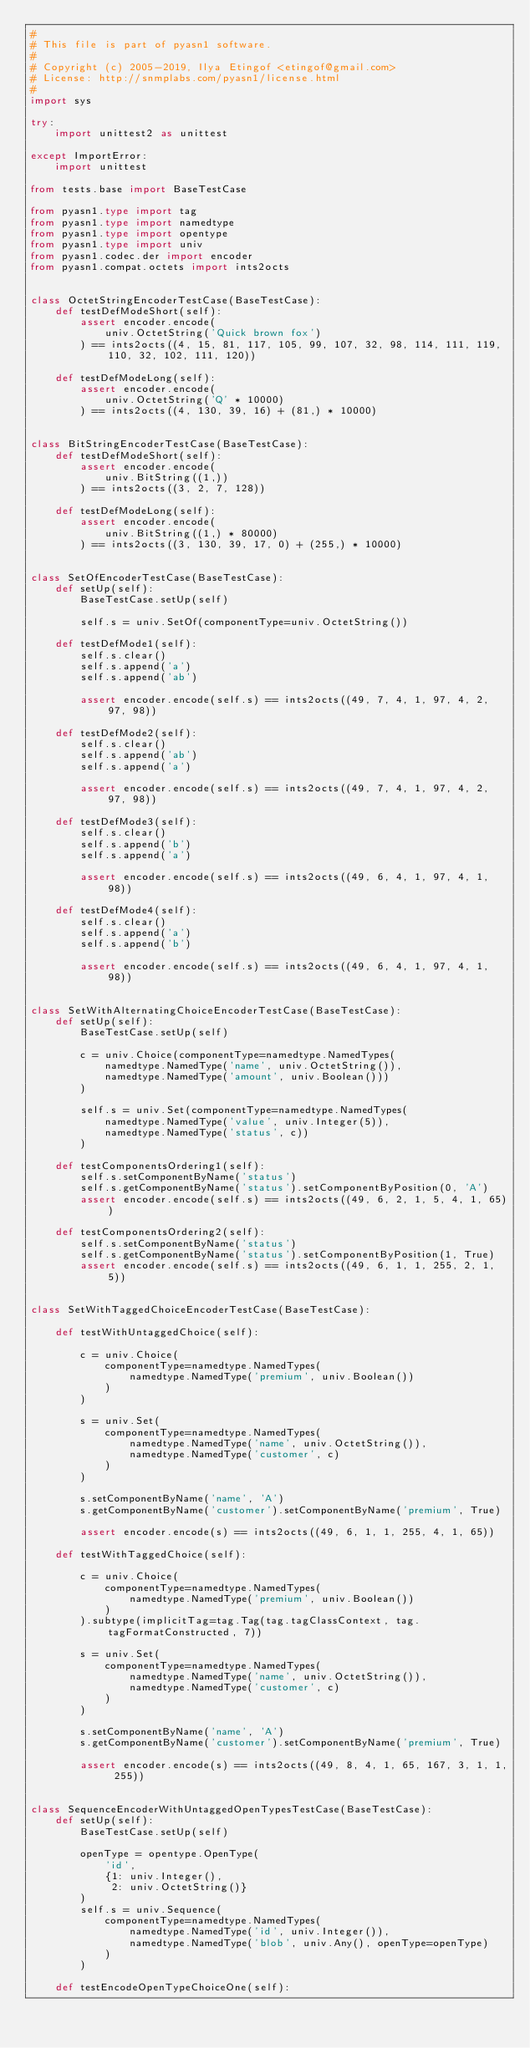<code> <loc_0><loc_0><loc_500><loc_500><_Python_>#
# This file is part of pyasn1 software.
#
# Copyright (c) 2005-2019, Ilya Etingof <etingof@gmail.com>
# License: http://snmplabs.com/pyasn1/license.html
#
import sys

try:
    import unittest2 as unittest

except ImportError:
    import unittest

from tests.base import BaseTestCase

from pyasn1.type import tag
from pyasn1.type import namedtype
from pyasn1.type import opentype
from pyasn1.type import univ
from pyasn1.codec.der import encoder
from pyasn1.compat.octets import ints2octs


class OctetStringEncoderTestCase(BaseTestCase):
    def testDefModeShort(self):
        assert encoder.encode(
            univ.OctetString('Quick brown fox')
        ) == ints2octs((4, 15, 81, 117, 105, 99, 107, 32, 98, 114, 111, 119, 110, 32, 102, 111, 120))

    def testDefModeLong(self):
        assert encoder.encode(
            univ.OctetString('Q' * 10000)
        ) == ints2octs((4, 130, 39, 16) + (81,) * 10000)


class BitStringEncoderTestCase(BaseTestCase):
    def testDefModeShort(self):
        assert encoder.encode(
            univ.BitString((1,))
        ) == ints2octs((3, 2, 7, 128))

    def testDefModeLong(self):
        assert encoder.encode(
            univ.BitString((1,) * 80000)
        ) == ints2octs((3, 130, 39, 17, 0) + (255,) * 10000)


class SetOfEncoderTestCase(BaseTestCase):
    def setUp(self):
        BaseTestCase.setUp(self)

        self.s = univ.SetOf(componentType=univ.OctetString())

    def testDefMode1(self):
        self.s.clear()
        self.s.append('a')
        self.s.append('ab')

        assert encoder.encode(self.s) == ints2octs((49, 7, 4, 1, 97, 4, 2, 97, 98))

    def testDefMode2(self):
        self.s.clear()
        self.s.append('ab')
        self.s.append('a')

        assert encoder.encode(self.s) == ints2octs((49, 7, 4, 1, 97, 4, 2, 97, 98))

    def testDefMode3(self):
        self.s.clear()
        self.s.append('b')
        self.s.append('a')

        assert encoder.encode(self.s) == ints2octs((49, 6, 4, 1, 97, 4, 1, 98))

    def testDefMode4(self):
        self.s.clear()
        self.s.append('a')
        self.s.append('b')

        assert encoder.encode(self.s) == ints2octs((49, 6, 4, 1, 97, 4, 1, 98))


class SetWithAlternatingChoiceEncoderTestCase(BaseTestCase):
    def setUp(self):
        BaseTestCase.setUp(self)

        c = univ.Choice(componentType=namedtype.NamedTypes(
            namedtype.NamedType('name', univ.OctetString()),
            namedtype.NamedType('amount', univ.Boolean()))
        )

        self.s = univ.Set(componentType=namedtype.NamedTypes(
            namedtype.NamedType('value', univ.Integer(5)),
            namedtype.NamedType('status', c))
        )

    def testComponentsOrdering1(self):
        self.s.setComponentByName('status')
        self.s.getComponentByName('status').setComponentByPosition(0, 'A')
        assert encoder.encode(self.s) == ints2octs((49, 6, 2, 1, 5, 4, 1, 65))

    def testComponentsOrdering2(self):
        self.s.setComponentByName('status')
        self.s.getComponentByName('status').setComponentByPosition(1, True)
        assert encoder.encode(self.s) == ints2octs((49, 6, 1, 1, 255, 2, 1, 5))


class SetWithTaggedChoiceEncoderTestCase(BaseTestCase):

    def testWithUntaggedChoice(self):

        c = univ.Choice(
            componentType=namedtype.NamedTypes(
                namedtype.NamedType('premium', univ.Boolean())
            )
        )

        s = univ.Set(
            componentType=namedtype.NamedTypes(
                namedtype.NamedType('name', univ.OctetString()),
                namedtype.NamedType('customer', c)
            )
        )

        s.setComponentByName('name', 'A')
        s.getComponentByName('customer').setComponentByName('premium', True)

        assert encoder.encode(s) == ints2octs((49, 6, 1, 1, 255, 4, 1, 65))

    def testWithTaggedChoice(self):

        c = univ.Choice(
            componentType=namedtype.NamedTypes(
                namedtype.NamedType('premium', univ.Boolean())
            )
        ).subtype(implicitTag=tag.Tag(tag.tagClassContext, tag.tagFormatConstructed, 7))

        s = univ.Set(
            componentType=namedtype.NamedTypes(
                namedtype.NamedType('name', univ.OctetString()),
                namedtype.NamedType('customer', c)
            )
        )

        s.setComponentByName('name', 'A')
        s.getComponentByName('customer').setComponentByName('premium', True)

        assert encoder.encode(s) == ints2octs((49, 8, 4, 1, 65, 167, 3, 1, 1, 255))


class SequenceEncoderWithUntaggedOpenTypesTestCase(BaseTestCase):
    def setUp(self):
        BaseTestCase.setUp(self)

        openType = opentype.OpenType(
            'id',
            {1: univ.Integer(),
             2: univ.OctetString()}
        )
        self.s = univ.Sequence(
            componentType=namedtype.NamedTypes(
                namedtype.NamedType('id', univ.Integer()),
                namedtype.NamedType('blob', univ.Any(), openType=openType)
            )
        )

    def testEncodeOpenTypeChoiceOne(self):</code> 